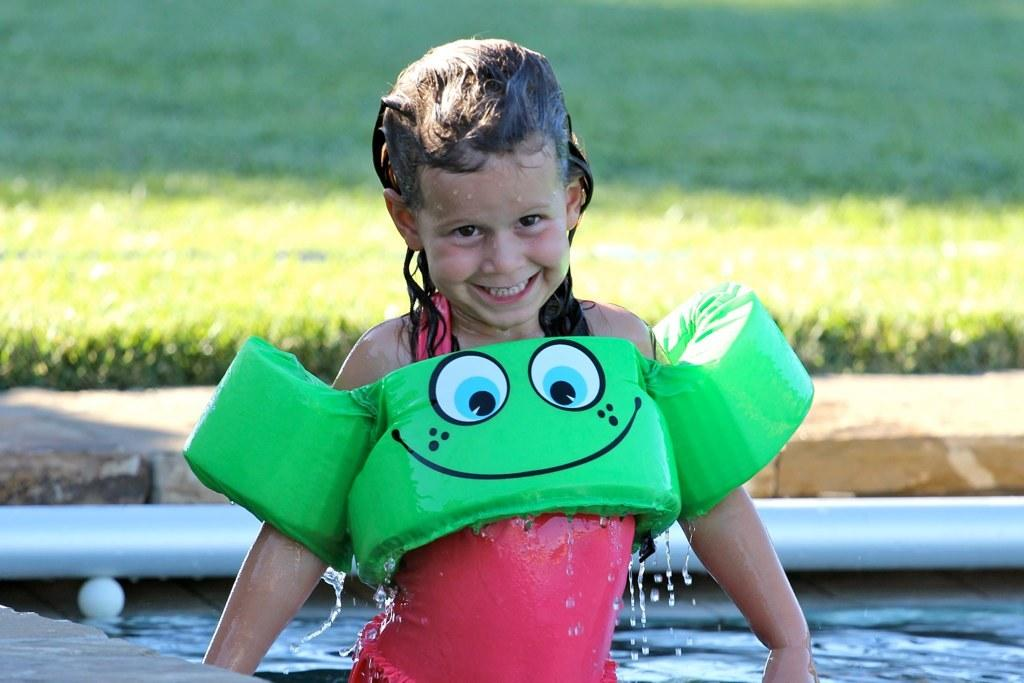What is the girl doing in the image? The girl is standing in the image and smiling. What is the condition of the water around the girl? There is water around the girl. What is located near the water? There is a pipe near the water. What type of vegetation is present on the ground behind the pipe? There is grass on the ground behind the pipe. How many snails are crawling on the quartz in the image? There is no quartz or snails present in the image. Is there a fight happening between the girl and the pipe in the image? No, there is no fight happening between the girl and the pipe in the image. 